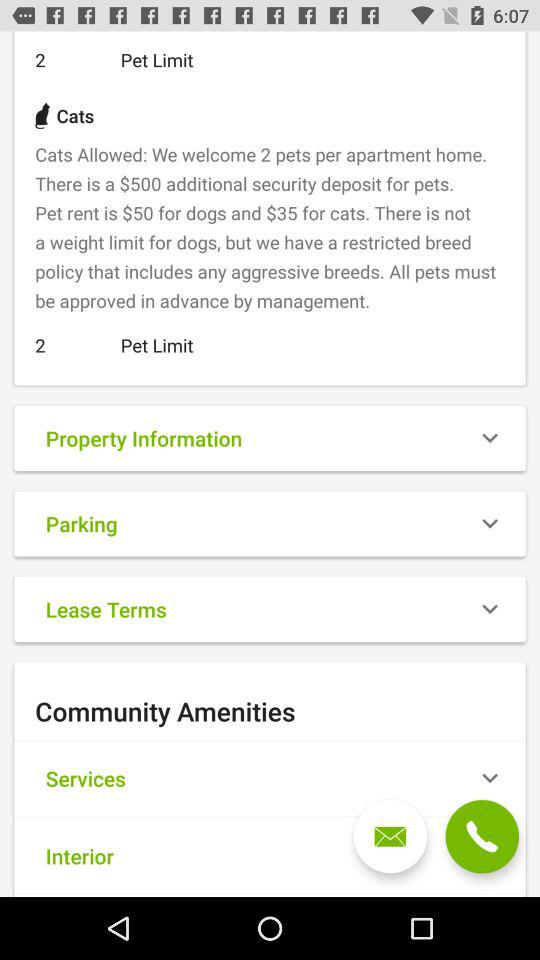What's the rent for cats? The rent for cats is $35. 